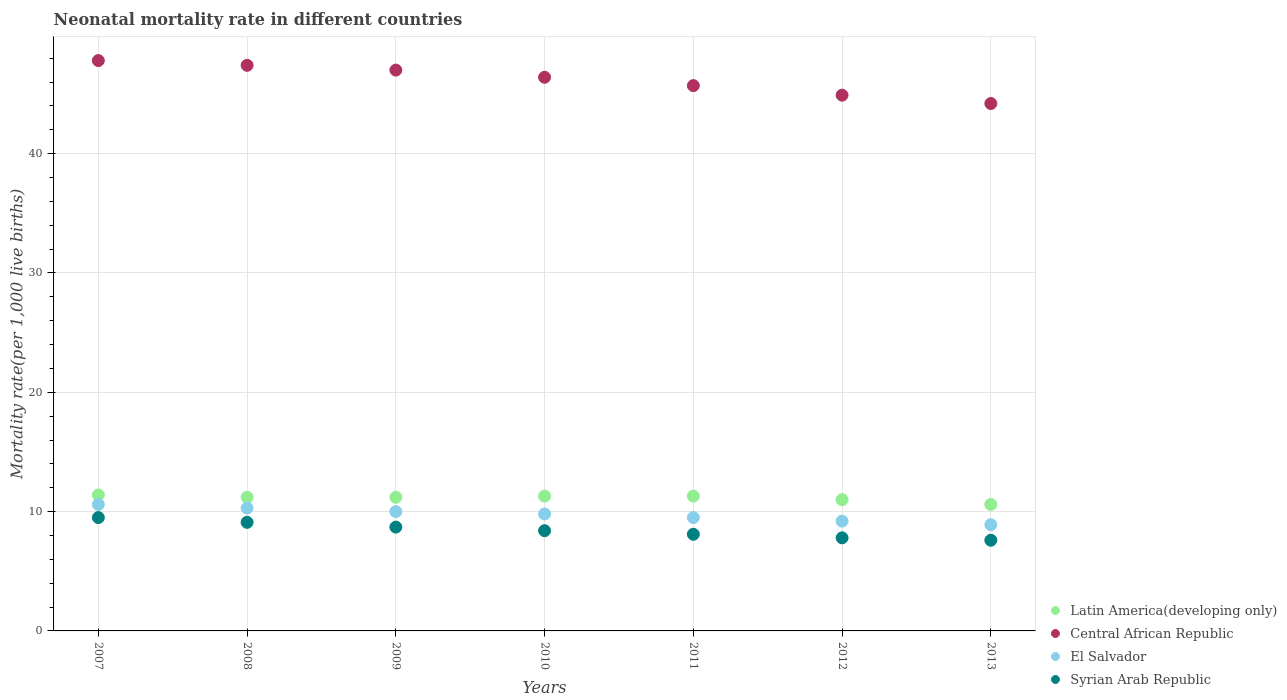How many different coloured dotlines are there?
Provide a succinct answer. 4. Is the number of dotlines equal to the number of legend labels?
Your answer should be compact. Yes. What is the neonatal mortality rate in Latin America(developing only) in 2013?
Give a very brief answer. 10.6. Across all years, what is the minimum neonatal mortality rate in El Salvador?
Your answer should be very brief. 8.9. In which year was the neonatal mortality rate in Latin America(developing only) maximum?
Your response must be concise. 2007. In which year was the neonatal mortality rate in Latin America(developing only) minimum?
Ensure brevity in your answer.  2013. What is the total neonatal mortality rate in Central African Republic in the graph?
Give a very brief answer. 323.4. What is the difference between the neonatal mortality rate in El Salvador in 2008 and that in 2009?
Provide a succinct answer. 0.3. What is the difference between the neonatal mortality rate in Central African Republic in 2013 and the neonatal mortality rate in Latin America(developing only) in 2010?
Offer a very short reply. 32.9. What is the average neonatal mortality rate in Syrian Arab Republic per year?
Offer a terse response. 8.46. In the year 2010, what is the difference between the neonatal mortality rate in Syrian Arab Republic and neonatal mortality rate in El Salvador?
Offer a very short reply. -1.4. What is the ratio of the neonatal mortality rate in Central African Republic in 2010 to that in 2011?
Your answer should be compact. 1.02. What is the difference between the highest and the second highest neonatal mortality rate in El Salvador?
Give a very brief answer. 0.3. What is the difference between the highest and the lowest neonatal mortality rate in El Salvador?
Your response must be concise. 1.7. Is the sum of the neonatal mortality rate in El Salvador in 2010 and 2012 greater than the maximum neonatal mortality rate in Central African Republic across all years?
Offer a terse response. No. Does the neonatal mortality rate in Syrian Arab Republic monotonically increase over the years?
Offer a terse response. No. Is the neonatal mortality rate in Latin America(developing only) strictly less than the neonatal mortality rate in Central African Republic over the years?
Provide a succinct answer. Yes. What is the difference between two consecutive major ticks on the Y-axis?
Your response must be concise. 10. Does the graph contain any zero values?
Offer a very short reply. No. Where does the legend appear in the graph?
Make the answer very short. Bottom right. What is the title of the graph?
Your answer should be compact. Neonatal mortality rate in different countries. Does "West Bank and Gaza" appear as one of the legend labels in the graph?
Give a very brief answer. No. What is the label or title of the X-axis?
Give a very brief answer. Years. What is the label or title of the Y-axis?
Your response must be concise. Mortality rate(per 1,0 live births). What is the Mortality rate(per 1,000 live births) in Central African Republic in 2007?
Give a very brief answer. 47.8. What is the Mortality rate(per 1,000 live births) of El Salvador in 2007?
Provide a short and direct response. 10.6. What is the Mortality rate(per 1,000 live births) of Syrian Arab Republic in 2007?
Provide a short and direct response. 9.5. What is the Mortality rate(per 1,000 live births) in Central African Republic in 2008?
Offer a very short reply. 47.4. What is the Mortality rate(per 1,000 live births) in El Salvador in 2008?
Ensure brevity in your answer.  10.3. What is the Mortality rate(per 1,000 live births) of Syrian Arab Republic in 2008?
Your answer should be compact. 9.1. What is the Mortality rate(per 1,000 live births) of Latin America(developing only) in 2009?
Keep it short and to the point. 11.2. What is the Mortality rate(per 1,000 live births) in Central African Republic in 2009?
Keep it short and to the point. 47. What is the Mortality rate(per 1,000 live births) in Syrian Arab Republic in 2009?
Make the answer very short. 8.7. What is the Mortality rate(per 1,000 live births) of Central African Republic in 2010?
Keep it short and to the point. 46.4. What is the Mortality rate(per 1,000 live births) of El Salvador in 2010?
Your response must be concise. 9.8. What is the Mortality rate(per 1,000 live births) of Syrian Arab Republic in 2010?
Make the answer very short. 8.4. What is the Mortality rate(per 1,000 live births) of Latin America(developing only) in 2011?
Your answer should be compact. 11.3. What is the Mortality rate(per 1,000 live births) of Central African Republic in 2011?
Provide a succinct answer. 45.7. What is the Mortality rate(per 1,000 live births) in Syrian Arab Republic in 2011?
Give a very brief answer. 8.1. What is the Mortality rate(per 1,000 live births) of Central African Republic in 2012?
Offer a terse response. 44.9. What is the Mortality rate(per 1,000 live births) of El Salvador in 2012?
Offer a very short reply. 9.2. What is the Mortality rate(per 1,000 live births) of Syrian Arab Republic in 2012?
Provide a short and direct response. 7.8. What is the Mortality rate(per 1,000 live births) in Latin America(developing only) in 2013?
Your answer should be very brief. 10.6. What is the Mortality rate(per 1,000 live births) in Central African Republic in 2013?
Offer a very short reply. 44.2. What is the Mortality rate(per 1,000 live births) in El Salvador in 2013?
Make the answer very short. 8.9. What is the Mortality rate(per 1,000 live births) in Syrian Arab Republic in 2013?
Give a very brief answer. 7.6. Across all years, what is the maximum Mortality rate(per 1,000 live births) of Latin America(developing only)?
Your answer should be compact. 11.4. Across all years, what is the maximum Mortality rate(per 1,000 live births) in Central African Republic?
Give a very brief answer. 47.8. Across all years, what is the maximum Mortality rate(per 1,000 live births) in El Salvador?
Provide a succinct answer. 10.6. Across all years, what is the maximum Mortality rate(per 1,000 live births) of Syrian Arab Republic?
Keep it short and to the point. 9.5. Across all years, what is the minimum Mortality rate(per 1,000 live births) of Latin America(developing only)?
Offer a very short reply. 10.6. Across all years, what is the minimum Mortality rate(per 1,000 live births) in Central African Republic?
Provide a succinct answer. 44.2. What is the total Mortality rate(per 1,000 live births) of Central African Republic in the graph?
Provide a succinct answer. 323.4. What is the total Mortality rate(per 1,000 live births) of El Salvador in the graph?
Your response must be concise. 68.3. What is the total Mortality rate(per 1,000 live births) of Syrian Arab Republic in the graph?
Offer a very short reply. 59.2. What is the difference between the Mortality rate(per 1,000 live births) in Latin America(developing only) in 2007 and that in 2008?
Provide a short and direct response. 0.2. What is the difference between the Mortality rate(per 1,000 live births) of El Salvador in 2007 and that in 2008?
Your answer should be compact. 0.3. What is the difference between the Mortality rate(per 1,000 live births) in Syrian Arab Republic in 2007 and that in 2008?
Your response must be concise. 0.4. What is the difference between the Mortality rate(per 1,000 live births) in Central African Republic in 2007 and that in 2009?
Give a very brief answer. 0.8. What is the difference between the Mortality rate(per 1,000 live births) in Syrian Arab Republic in 2007 and that in 2009?
Your answer should be compact. 0.8. What is the difference between the Mortality rate(per 1,000 live births) in El Salvador in 2007 and that in 2010?
Offer a terse response. 0.8. What is the difference between the Mortality rate(per 1,000 live births) in Syrian Arab Republic in 2007 and that in 2010?
Offer a terse response. 1.1. What is the difference between the Mortality rate(per 1,000 live births) in Central African Republic in 2007 and that in 2012?
Provide a short and direct response. 2.9. What is the difference between the Mortality rate(per 1,000 live births) in Syrian Arab Republic in 2007 and that in 2012?
Offer a very short reply. 1.7. What is the difference between the Mortality rate(per 1,000 live births) in Central African Republic in 2007 and that in 2013?
Offer a very short reply. 3.6. What is the difference between the Mortality rate(per 1,000 live births) of El Salvador in 2007 and that in 2013?
Provide a short and direct response. 1.7. What is the difference between the Mortality rate(per 1,000 live births) in Latin America(developing only) in 2008 and that in 2009?
Your answer should be compact. 0. What is the difference between the Mortality rate(per 1,000 live births) of Central African Republic in 2008 and that in 2009?
Provide a succinct answer. 0.4. What is the difference between the Mortality rate(per 1,000 live births) in Latin America(developing only) in 2008 and that in 2010?
Provide a succinct answer. -0.1. What is the difference between the Mortality rate(per 1,000 live births) of Central African Republic in 2008 and that in 2010?
Offer a terse response. 1. What is the difference between the Mortality rate(per 1,000 live births) in El Salvador in 2008 and that in 2010?
Offer a very short reply. 0.5. What is the difference between the Mortality rate(per 1,000 live births) in Central African Republic in 2008 and that in 2011?
Provide a short and direct response. 1.7. What is the difference between the Mortality rate(per 1,000 live births) in El Salvador in 2008 and that in 2011?
Keep it short and to the point. 0.8. What is the difference between the Mortality rate(per 1,000 live births) of Latin America(developing only) in 2008 and that in 2012?
Your response must be concise. 0.2. What is the difference between the Mortality rate(per 1,000 live births) in Syrian Arab Republic in 2008 and that in 2012?
Offer a very short reply. 1.3. What is the difference between the Mortality rate(per 1,000 live births) of Latin America(developing only) in 2008 and that in 2013?
Offer a very short reply. 0.6. What is the difference between the Mortality rate(per 1,000 live births) of Central African Republic in 2009 and that in 2010?
Your answer should be compact. 0.6. What is the difference between the Mortality rate(per 1,000 live births) in El Salvador in 2009 and that in 2010?
Provide a succinct answer. 0.2. What is the difference between the Mortality rate(per 1,000 live births) in Syrian Arab Republic in 2009 and that in 2010?
Offer a very short reply. 0.3. What is the difference between the Mortality rate(per 1,000 live births) of Central African Republic in 2009 and that in 2011?
Your response must be concise. 1.3. What is the difference between the Mortality rate(per 1,000 live births) of El Salvador in 2009 and that in 2011?
Provide a succinct answer. 0.5. What is the difference between the Mortality rate(per 1,000 live births) of Central African Republic in 2009 and that in 2012?
Give a very brief answer. 2.1. What is the difference between the Mortality rate(per 1,000 live births) in El Salvador in 2009 and that in 2012?
Offer a very short reply. 0.8. What is the difference between the Mortality rate(per 1,000 live births) in Syrian Arab Republic in 2009 and that in 2012?
Your answer should be compact. 0.9. What is the difference between the Mortality rate(per 1,000 live births) in Latin America(developing only) in 2009 and that in 2013?
Offer a very short reply. 0.6. What is the difference between the Mortality rate(per 1,000 live births) in Central African Republic in 2010 and that in 2011?
Provide a succinct answer. 0.7. What is the difference between the Mortality rate(per 1,000 live births) of Syrian Arab Republic in 2010 and that in 2011?
Ensure brevity in your answer.  0.3. What is the difference between the Mortality rate(per 1,000 live births) in Latin America(developing only) in 2010 and that in 2012?
Your answer should be compact. 0.3. What is the difference between the Mortality rate(per 1,000 live births) of Central African Republic in 2010 and that in 2012?
Make the answer very short. 1.5. What is the difference between the Mortality rate(per 1,000 live births) in Syrian Arab Republic in 2010 and that in 2012?
Provide a short and direct response. 0.6. What is the difference between the Mortality rate(per 1,000 live births) in Central African Republic in 2010 and that in 2013?
Provide a succinct answer. 2.2. What is the difference between the Mortality rate(per 1,000 live births) of El Salvador in 2010 and that in 2013?
Make the answer very short. 0.9. What is the difference between the Mortality rate(per 1,000 live births) in Latin America(developing only) in 2011 and that in 2012?
Ensure brevity in your answer.  0.3. What is the difference between the Mortality rate(per 1,000 live births) in El Salvador in 2011 and that in 2012?
Offer a very short reply. 0.3. What is the difference between the Mortality rate(per 1,000 live births) in Syrian Arab Republic in 2011 and that in 2012?
Your answer should be very brief. 0.3. What is the difference between the Mortality rate(per 1,000 live births) in Central African Republic in 2011 and that in 2013?
Give a very brief answer. 1.5. What is the difference between the Mortality rate(per 1,000 live births) in El Salvador in 2011 and that in 2013?
Your answer should be very brief. 0.6. What is the difference between the Mortality rate(per 1,000 live births) in Syrian Arab Republic in 2011 and that in 2013?
Provide a short and direct response. 0.5. What is the difference between the Mortality rate(per 1,000 live births) in Central African Republic in 2012 and that in 2013?
Give a very brief answer. 0.7. What is the difference between the Mortality rate(per 1,000 live births) of Latin America(developing only) in 2007 and the Mortality rate(per 1,000 live births) of Central African Republic in 2008?
Offer a very short reply. -36. What is the difference between the Mortality rate(per 1,000 live births) of Latin America(developing only) in 2007 and the Mortality rate(per 1,000 live births) of Syrian Arab Republic in 2008?
Give a very brief answer. 2.3. What is the difference between the Mortality rate(per 1,000 live births) of Central African Republic in 2007 and the Mortality rate(per 1,000 live births) of El Salvador in 2008?
Your answer should be compact. 37.5. What is the difference between the Mortality rate(per 1,000 live births) in Central African Republic in 2007 and the Mortality rate(per 1,000 live births) in Syrian Arab Republic in 2008?
Give a very brief answer. 38.7. What is the difference between the Mortality rate(per 1,000 live births) of Latin America(developing only) in 2007 and the Mortality rate(per 1,000 live births) of Central African Republic in 2009?
Offer a very short reply. -35.6. What is the difference between the Mortality rate(per 1,000 live births) in Latin America(developing only) in 2007 and the Mortality rate(per 1,000 live births) in El Salvador in 2009?
Your answer should be very brief. 1.4. What is the difference between the Mortality rate(per 1,000 live births) of Latin America(developing only) in 2007 and the Mortality rate(per 1,000 live births) of Syrian Arab Republic in 2009?
Your answer should be very brief. 2.7. What is the difference between the Mortality rate(per 1,000 live births) in Central African Republic in 2007 and the Mortality rate(per 1,000 live births) in El Salvador in 2009?
Keep it short and to the point. 37.8. What is the difference between the Mortality rate(per 1,000 live births) in Central African Republic in 2007 and the Mortality rate(per 1,000 live births) in Syrian Arab Republic in 2009?
Ensure brevity in your answer.  39.1. What is the difference between the Mortality rate(per 1,000 live births) of El Salvador in 2007 and the Mortality rate(per 1,000 live births) of Syrian Arab Republic in 2009?
Your answer should be compact. 1.9. What is the difference between the Mortality rate(per 1,000 live births) of Latin America(developing only) in 2007 and the Mortality rate(per 1,000 live births) of Central African Republic in 2010?
Keep it short and to the point. -35. What is the difference between the Mortality rate(per 1,000 live births) of Latin America(developing only) in 2007 and the Mortality rate(per 1,000 live births) of El Salvador in 2010?
Keep it short and to the point. 1.6. What is the difference between the Mortality rate(per 1,000 live births) in Central African Republic in 2007 and the Mortality rate(per 1,000 live births) in El Salvador in 2010?
Provide a short and direct response. 38. What is the difference between the Mortality rate(per 1,000 live births) in Central African Republic in 2007 and the Mortality rate(per 1,000 live births) in Syrian Arab Republic in 2010?
Give a very brief answer. 39.4. What is the difference between the Mortality rate(per 1,000 live births) of Latin America(developing only) in 2007 and the Mortality rate(per 1,000 live births) of Central African Republic in 2011?
Keep it short and to the point. -34.3. What is the difference between the Mortality rate(per 1,000 live births) in Latin America(developing only) in 2007 and the Mortality rate(per 1,000 live births) in El Salvador in 2011?
Ensure brevity in your answer.  1.9. What is the difference between the Mortality rate(per 1,000 live births) of Latin America(developing only) in 2007 and the Mortality rate(per 1,000 live births) of Syrian Arab Republic in 2011?
Provide a succinct answer. 3.3. What is the difference between the Mortality rate(per 1,000 live births) of Central African Republic in 2007 and the Mortality rate(per 1,000 live births) of El Salvador in 2011?
Your answer should be compact. 38.3. What is the difference between the Mortality rate(per 1,000 live births) in Central African Republic in 2007 and the Mortality rate(per 1,000 live births) in Syrian Arab Republic in 2011?
Your answer should be compact. 39.7. What is the difference between the Mortality rate(per 1,000 live births) of Latin America(developing only) in 2007 and the Mortality rate(per 1,000 live births) of Central African Republic in 2012?
Your answer should be very brief. -33.5. What is the difference between the Mortality rate(per 1,000 live births) in Latin America(developing only) in 2007 and the Mortality rate(per 1,000 live births) in El Salvador in 2012?
Your answer should be compact. 2.2. What is the difference between the Mortality rate(per 1,000 live births) in Central African Republic in 2007 and the Mortality rate(per 1,000 live births) in El Salvador in 2012?
Your response must be concise. 38.6. What is the difference between the Mortality rate(per 1,000 live births) of Latin America(developing only) in 2007 and the Mortality rate(per 1,000 live births) of Central African Republic in 2013?
Ensure brevity in your answer.  -32.8. What is the difference between the Mortality rate(per 1,000 live births) in Latin America(developing only) in 2007 and the Mortality rate(per 1,000 live births) in Syrian Arab Republic in 2013?
Provide a succinct answer. 3.8. What is the difference between the Mortality rate(per 1,000 live births) of Central African Republic in 2007 and the Mortality rate(per 1,000 live births) of El Salvador in 2013?
Your response must be concise. 38.9. What is the difference between the Mortality rate(per 1,000 live births) in Central African Republic in 2007 and the Mortality rate(per 1,000 live births) in Syrian Arab Republic in 2013?
Offer a very short reply. 40.2. What is the difference between the Mortality rate(per 1,000 live births) in Latin America(developing only) in 2008 and the Mortality rate(per 1,000 live births) in Central African Republic in 2009?
Your answer should be compact. -35.8. What is the difference between the Mortality rate(per 1,000 live births) of Latin America(developing only) in 2008 and the Mortality rate(per 1,000 live births) of El Salvador in 2009?
Give a very brief answer. 1.2. What is the difference between the Mortality rate(per 1,000 live births) in Central African Republic in 2008 and the Mortality rate(per 1,000 live births) in El Salvador in 2009?
Your response must be concise. 37.4. What is the difference between the Mortality rate(per 1,000 live births) in Central African Republic in 2008 and the Mortality rate(per 1,000 live births) in Syrian Arab Republic in 2009?
Keep it short and to the point. 38.7. What is the difference between the Mortality rate(per 1,000 live births) of El Salvador in 2008 and the Mortality rate(per 1,000 live births) of Syrian Arab Republic in 2009?
Your answer should be very brief. 1.6. What is the difference between the Mortality rate(per 1,000 live births) of Latin America(developing only) in 2008 and the Mortality rate(per 1,000 live births) of Central African Republic in 2010?
Your response must be concise. -35.2. What is the difference between the Mortality rate(per 1,000 live births) of Latin America(developing only) in 2008 and the Mortality rate(per 1,000 live births) of Syrian Arab Republic in 2010?
Your answer should be compact. 2.8. What is the difference between the Mortality rate(per 1,000 live births) in Central African Republic in 2008 and the Mortality rate(per 1,000 live births) in El Salvador in 2010?
Keep it short and to the point. 37.6. What is the difference between the Mortality rate(per 1,000 live births) in Central African Republic in 2008 and the Mortality rate(per 1,000 live births) in Syrian Arab Republic in 2010?
Your answer should be very brief. 39. What is the difference between the Mortality rate(per 1,000 live births) of El Salvador in 2008 and the Mortality rate(per 1,000 live births) of Syrian Arab Republic in 2010?
Your answer should be compact. 1.9. What is the difference between the Mortality rate(per 1,000 live births) of Latin America(developing only) in 2008 and the Mortality rate(per 1,000 live births) of Central African Republic in 2011?
Provide a succinct answer. -34.5. What is the difference between the Mortality rate(per 1,000 live births) of Latin America(developing only) in 2008 and the Mortality rate(per 1,000 live births) of Syrian Arab Republic in 2011?
Your answer should be compact. 3.1. What is the difference between the Mortality rate(per 1,000 live births) in Central African Republic in 2008 and the Mortality rate(per 1,000 live births) in El Salvador in 2011?
Offer a very short reply. 37.9. What is the difference between the Mortality rate(per 1,000 live births) of Central African Republic in 2008 and the Mortality rate(per 1,000 live births) of Syrian Arab Republic in 2011?
Provide a succinct answer. 39.3. What is the difference between the Mortality rate(per 1,000 live births) in Latin America(developing only) in 2008 and the Mortality rate(per 1,000 live births) in Central African Republic in 2012?
Your answer should be very brief. -33.7. What is the difference between the Mortality rate(per 1,000 live births) in Latin America(developing only) in 2008 and the Mortality rate(per 1,000 live births) in Syrian Arab Republic in 2012?
Your response must be concise. 3.4. What is the difference between the Mortality rate(per 1,000 live births) in Central African Republic in 2008 and the Mortality rate(per 1,000 live births) in El Salvador in 2012?
Offer a very short reply. 38.2. What is the difference between the Mortality rate(per 1,000 live births) in Central African Republic in 2008 and the Mortality rate(per 1,000 live births) in Syrian Arab Republic in 2012?
Your answer should be compact. 39.6. What is the difference between the Mortality rate(per 1,000 live births) of El Salvador in 2008 and the Mortality rate(per 1,000 live births) of Syrian Arab Republic in 2012?
Give a very brief answer. 2.5. What is the difference between the Mortality rate(per 1,000 live births) of Latin America(developing only) in 2008 and the Mortality rate(per 1,000 live births) of Central African Republic in 2013?
Your response must be concise. -33. What is the difference between the Mortality rate(per 1,000 live births) of Latin America(developing only) in 2008 and the Mortality rate(per 1,000 live births) of El Salvador in 2013?
Provide a short and direct response. 2.3. What is the difference between the Mortality rate(per 1,000 live births) of Latin America(developing only) in 2008 and the Mortality rate(per 1,000 live births) of Syrian Arab Republic in 2013?
Keep it short and to the point. 3.6. What is the difference between the Mortality rate(per 1,000 live births) in Central African Republic in 2008 and the Mortality rate(per 1,000 live births) in El Salvador in 2013?
Keep it short and to the point. 38.5. What is the difference between the Mortality rate(per 1,000 live births) in Central African Republic in 2008 and the Mortality rate(per 1,000 live births) in Syrian Arab Republic in 2013?
Your response must be concise. 39.8. What is the difference between the Mortality rate(per 1,000 live births) in Latin America(developing only) in 2009 and the Mortality rate(per 1,000 live births) in Central African Republic in 2010?
Offer a terse response. -35.2. What is the difference between the Mortality rate(per 1,000 live births) in Central African Republic in 2009 and the Mortality rate(per 1,000 live births) in El Salvador in 2010?
Provide a succinct answer. 37.2. What is the difference between the Mortality rate(per 1,000 live births) in Central African Republic in 2009 and the Mortality rate(per 1,000 live births) in Syrian Arab Republic in 2010?
Your answer should be very brief. 38.6. What is the difference between the Mortality rate(per 1,000 live births) of El Salvador in 2009 and the Mortality rate(per 1,000 live births) of Syrian Arab Republic in 2010?
Provide a short and direct response. 1.6. What is the difference between the Mortality rate(per 1,000 live births) in Latin America(developing only) in 2009 and the Mortality rate(per 1,000 live births) in Central African Republic in 2011?
Make the answer very short. -34.5. What is the difference between the Mortality rate(per 1,000 live births) in Latin America(developing only) in 2009 and the Mortality rate(per 1,000 live births) in El Salvador in 2011?
Keep it short and to the point. 1.7. What is the difference between the Mortality rate(per 1,000 live births) of Central African Republic in 2009 and the Mortality rate(per 1,000 live births) of El Salvador in 2011?
Your response must be concise. 37.5. What is the difference between the Mortality rate(per 1,000 live births) in Central African Republic in 2009 and the Mortality rate(per 1,000 live births) in Syrian Arab Republic in 2011?
Ensure brevity in your answer.  38.9. What is the difference between the Mortality rate(per 1,000 live births) of El Salvador in 2009 and the Mortality rate(per 1,000 live births) of Syrian Arab Republic in 2011?
Provide a short and direct response. 1.9. What is the difference between the Mortality rate(per 1,000 live births) in Latin America(developing only) in 2009 and the Mortality rate(per 1,000 live births) in Central African Republic in 2012?
Ensure brevity in your answer.  -33.7. What is the difference between the Mortality rate(per 1,000 live births) of Latin America(developing only) in 2009 and the Mortality rate(per 1,000 live births) of El Salvador in 2012?
Offer a very short reply. 2. What is the difference between the Mortality rate(per 1,000 live births) in Central African Republic in 2009 and the Mortality rate(per 1,000 live births) in El Salvador in 2012?
Your answer should be compact. 37.8. What is the difference between the Mortality rate(per 1,000 live births) of Central African Republic in 2009 and the Mortality rate(per 1,000 live births) of Syrian Arab Republic in 2012?
Provide a short and direct response. 39.2. What is the difference between the Mortality rate(per 1,000 live births) in El Salvador in 2009 and the Mortality rate(per 1,000 live births) in Syrian Arab Republic in 2012?
Ensure brevity in your answer.  2.2. What is the difference between the Mortality rate(per 1,000 live births) of Latin America(developing only) in 2009 and the Mortality rate(per 1,000 live births) of Central African Republic in 2013?
Give a very brief answer. -33. What is the difference between the Mortality rate(per 1,000 live births) of Central African Republic in 2009 and the Mortality rate(per 1,000 live births) of El Salvador in 2013?
Provide a short and direct response. 38.1. What is the difference between the Mortality rate(per 1,000 live births) of Central African Republic in 2009 and the Mortality rate(per 1,000 live births) of Syrian Arab Republic in 2013?
Ensure brevity in your answer.  39.4. What is the difference between the Mortality rate(per 1,000 live births) in Latin America(developing only) in 2010 and the Mortality rate(per 1,000 live births) in Central African Republic in 2011?
Provide a short and direct response. -34.4. What is the difference between the Mortality rate(per 1,000 live births) of Latin America(developing only) in 2010 and the Mortality rate(per 1,000 live births) of El Salvador in 2011?
Provide a short and direct response. 1.8. What is the difference between the Mortality rate(per 1,000 live births) of Latin America(developing only) in 2010 and the Mortality rate(per 1,000 live births) of Syrian Arab Republic in 2011?
Provide a short and direct response. 3.2. What is the difference between the Mortality rate(per 1,000 live births) of Central African Republic in 2010 and the Mortality rate(per 1,000 live births) of El Salvador in 2011?
Your response must be concise. 36.9. What is the difference between the Mortality rate(per 1,000 live births) of Central African Republic in 2010 and the Mortality rate(per 1,000 live births) of Syrian Arab Republic in 2011?
Your answer should be very brief. 38.3. What is the difference between the Mortality rate(per 1,000 live births) in El Salvador in 2010 and the Mortality rate(per 1,000 live births) in Syrian Arab Republic in 2011?
Keep it short and to the point. 1.7. What is the difference between the Mortality rate(per 1,000 live births) in Latin America(developing only) in 2010 and the Mortality rate(per 1,000 live births) in Central African Republic in 2012?
Provide a succinct answer. -33.6. What is the difference between the Mortality rate(per 1,000 live births) in Latin America(developing only) in 2010 and the Mortality rate(per 1,000 live births) in El Salvador in 2012?
Make the answer very short. 2.1. What is the difference between the Mortality rate(per 1,000 live births) of Central African Republic in 2010 and the Mortality rate(per 1,000 live births) of El Salvador in 2012?
Provide a short and direct response. 37.2. What is the difference between the Mortality rate(per 1,000 live births) in Central African Republic in 2010 and the Mortality rate(per 1,000 live births) in Syrian Arab Republic in 2012?
Keep it short and to the point. 38.6. What is the difference between the Mortality rate(per 1,000 live births) in Latin America(developing only) in 2010 and the Mortality rate(per 1,000 live births) in Central African Republic in 2013?
Your response must be concise. -32.9. What is the difference between the Mortality rate(per 1,000 live births) in Latin America(developing only) in 2010 and the Mortality rate(per 1,000 live births) in El Salvador in 2013?
Give a very brief answer. 2.4. What is the difference between the Mortality rate(per 1,000 live births) in Central African Republic in 2010 and the Mortality rate(per 1,000 live births) in El Salvador in 2013?
Give a very brief answer. 37.5. What is the difference between the Mortality rate(per 1,000 live births) of Central African Republic in 2010 and the Mortality rate(per 1,000 live births) of Syrian Arab Republic in 2013?
Provide a succinct answer. 38.8. What is the difference between the Mortality rate(per 1,000 live births) of El Salvador in 2010 and the Mortality rate(per 1,000 live births) of Syrian Arab Republic in 2013?
Your answer should be compact. 2.2. What is the difference between the Mortality rate(per 1,000 live births) in Latin America(developing only) in 2011 and the Mortality rate(per 1,000 live births) in Central African Republic in 2012?
Provide a succinct answer. -33.6. What is the difference between the Mortality rate(per 1,000 live births) of Latin America(developing only) in 2011 and the Mortality rate(per 1,000 live births) of El Salvador in 2012?
Your answer should be compact. 2.1. What is the difference between the Mortality rate(per 1,000 live births) in Central African Republic in 2011 and the Mortality rate(per 1,000 live births) in El Salvador in 2012?
Provide a succinct answer. 36.5. What is the difference between the Mortality rate(per 1,000 live births) of Central African Republic in 2011 and the Mortality rate(per 1,000 live births) of Syrian Arab Republic in 2012?
Make the answer very short. 37.9. What is the difference between the Mortality rate(per 1,000 live births) in El Salvador in 2011 and the Mortality rate(per 1,000 live births) in Syrian Arab Republic in 2012?
Your answer should be compact. 1.7. What is the difference between the Mortality rate(per 1,000 live births) of Latin America(developing only) in 2011 and the Mortality rate(per 1,000 live births) of Central African Republic in 2013?
Keep it short and to the point. -32.9. What is the difference between the Mortality rate(per 1,000 live births) of Central African Republic in 2011 and the Mortality rate(per 1,000 live births) of El Salvador in 2013?
Your answer should be very brief. 36.8. What is the difference between the Mortality rate(per 1,000 live births) of Central African Republic in 2011 and the Mortality rate(per 1,000 live births) of Syrian Arab Republic in 2013?
Offer a terse response. 38.1. What is the difference between the Mortality rate(per 1,000 live births) of El Salvador in 2011 and the Mortality rate(per 1,000 live births) of Syrian Arab Republic in 2013?
Provide a succinct answer. 1.9. What is the difference between the Mortality rate(per 1,000 live births) of Latin America(developing only) in 2012 and the Mortality rate(per 1,000 live births) of Central African Republic in 2013?
Provide a short and direct response. -33.2. What is the difference between the Mortality rate(per 1,000 live births) in Latin America(developing only) in 2012 and the Mortality rate(per 1,000 live births) in Syrian Arab Republic in 2013?
Ensure brevity in your answer.  3.4. What is the difference between the Mortality rate(per 1,000 live births) of Central African Republic in 2012 and the Mortality rate(per 1,000 live births) of El Salvador in 2013?
Give a very brief answer. 36. What is the difference between the Mortality rate(per 1,000 live births) of Central African Republic in 2012 and the Mortality rate(per 1,000 live births) of Syrian Arab Republic in 2013?
Ensure brevity in your answer.  37.3. What is the difference between the Mortality rate(per 1,000 live births) in El Salvador in 2012 and the Mortality rate(per 1,000 live births) in Syrian Arab Republic in 2013?
Give a very brief answer. 1.6. What is the average Mortality rate(per 1,000 live births) in Latin America(developing only) per year?
Give a very brief answer. 11.14. What is the average Mortality rate(per 1,000 live births) in Central African Republic per year?
Provide a succinct answer. 46.2. What is the average Mortality rate(per 1,000 live births) of El Salvador per year?
Your answer should be very brief. 9.76. What is the average Mortality rate(per 1,000 live births) in Syrian Arab Republic per year?
Offer a very short reply. 8.46. In the year 2007, what is the difference between the Mortality rate(per 1,000 live births) of Latin America(developing only) and Mortality rate(per 1,000 live births) of Central African Republic?
Your answer should be compact. -36.4. In the year 2007, what is the difference between the Mortality rate(per 1,000 live births) in Latin America(developing only) and Mortality rate(per 1,000 live births) in Syrian Arab Republic?
Your answer should be very brief. 1.9. In the year 2007, what is the difference between the Mortality rate(per 1,000 live births) of Central African Republic and Mortality rate(per 1,000 live births) of El Salvador?
Keep it short and to the point. 37.2. In the year 2007, what is the difference between the Mortality rate(per 1,000 live births) in Central African Republic and Mortality rate(per 1,000 live births) in Syrian Arab Republic?
Provide a short and direct response. 38.3. In the year 2007, what is the difference between the Mortality rate(per 1,000 live births) of El Salvador and Mortality rate(per 1,000 live births) of Syrian Arab Republic?
Your answer should be very brief. 1.1. In the year 2008, what is the difference between the Mortality rate(per 1,000 live births) in Latin America(developing only) and Mortality rate(per 1,000 live births) in Central African Republic?
Offer a terse response. -36.2. In the year 2008, what is the difference between the Mortality rate(per 1,000 live births) of Latin America(developing only) and Mortality rate(per 1,000 live births) of El Salvador?
Your response must be concise. 0.9. In the year 2008, what is the difference between the Mortality rate(per 1,000 live births) in Latin America(developing only) and Mortality rate(per 1,000 live births) in Syrian Arab Republic?
Provide a succinct answer. 2.1. In the year 2008, what is the difference between the Mortality rate(per 1,000 live births) of Central African Republic and Mortality rate(per 1,000 live births) of El Salvador?
Make the answer very short. 37.1. In the year 2008, what is the difference between the Mortality rate(per 1,000 live births) in Central African Republic and Mortality rate(per 1,000 live births) in Syrian Arab Republic?
Provide a succinct answer. 38.3. In the year 2009, what is the difference between the Mortality rate(per 1,000 live births) of Latin America(developing only) and Mortality rate(per 1,000 live births) of Central African Republic?
Provide a succinct answer. -35.8. In the year 2009, what is the difference between the Mortality rate(per 1,000 live births) of Latin America(developing only) and Mortality rate(per 1,000 live births) of El Salvador?
Keep it short and to the point. 1.2. In the year 2009, what is the difference between the Mortality rate(per 1,000 live births) in Central African Republic and Mortality rate(per 1,000 live births) in Syrian Arab Republic?
Your response must be concise. 38.3. In the year 2010, what is the difference between the Mortality rate(per 1,000 live births) of Latin America(developing only) and Mortality rate(per 1,000 live births) of Central African Republic?
Offer a terse response. -35.1. In the year 2010, what is the difference between the Mortality rate(per 1,000 live births) in Latin America(developing only) and Mortality rate(per 1,000 live births) in Syrian Arab Republic?
Give a very brief answer. 2.9. In the year 2010, what is the difference between the Mortality rate(per 1,000 live births) in Central African Republic and Mortality rate(per 1,000 live births) in El Salvador?
Provide a succinct answer. 36.6. In the year 2010, what is the difference between the Mortality rate(per 1,000 live births) in Central African Republic and Mortality rate(per 1,000 live births) in Syrian Arab Republic?
Make the answer very short. 38. In the year 2011, what is the difference between the Mortality rate(per 1,000 live births) of Latin America(developing only) and Mortality rate(per 1,000 live births) of Central African Republic?
Offer a very short reply. -34.4. In the year 2011, what is the difference between the Mortality rate(per 1,000 live births) of Latin America(developing only) and Mortality rate(per 1,000 live births) of El Salvador?
Provide a succinct answer. 1.8. In the year 2011, what is the difference between the Mortality rate(per 1,000 live births) in Central African Republic and Mortality rate(per 1,000 live births) in El Salvador?
Your response must be concise. 36.2. In the year 2011, what is the difference between the Mortality rate(per 1,000 live births) in Central African Republic and Mortality rate(per 1,000 live births) in Syrian Arab Republic?
Your response must be concise. 37.6. In the year 2012, what is the difference between the Mortality rate(per 1,000 live births) of Latin America(developing only) and Mortality rate(per 1,000 live births) of Central African Republic?
Provide a short and direct response. -33.9. In the year 2012, what is the difference between the Mortality rate(per 1,000 live births) of Latin America(developing only) and Mortality rate(per 1,000 live births) of El Salvador?
Your response must be concise. 1.8. In the year 2012, what is the difference between the Mortality rate(per 1,000 live births) in Latin America(developing only) and Mortality rate(per 1,000 live births) in Syrian Arab Republic?
Offer a very short reply. 3.2. In the year 2012, what is the difference between the Mortality rate(per 1,000 live births) of Central African Republic and Mortality rate(per 1,000 live births) of El Salvador?
Give a very brief answer. 35.7. In the year 2012, what is the difference between the Mortality rate(per 1,000 live births) of Central African Republic and Mortality rate(per 1,000 live births) of Syrian Arab Republic?
Keep it short and to the point. 37.1. In the year 2013, what is the difference between the Mortality rate(per 1,000 live births) in Latin America(developing only) and Mortality rate(per 1,000 live births) in Central African Republic?
Keep it short and to the point. -33.6. In the year 2013, what is the difference between the Mortality rate(per 1,000 live births) of Latin America(developing only) and Mortality rate(per 1,000 live births) of El Salvador?
Offer a terse response. 1.7. In the year 2013, what is the difference between the Mortality rate(per 1,000 live births) of Latin America(developing only) and Mortality rate(per 1,000 live births) of Syrian Arab Republic?
Your answer should be compact. 3. In the year 2013, what is the difference between the Mortality rate(per 1,000 live births) of Central African Republic and Mortality rate(per 1,000 live births) of El Salvador?
Your answer should be compact. 35.3. In the year 2013, what is the difference between the Mortality rate(per 1,000 live births) in Central African Republic and Mortality rate(per 1,000 live births) in Syrian Arab Republic?
Your response must be concise. 36.6. What is the ratio of the Mortality rate(per 1,000 live births) of Latin America(developing only) in 2007 to that in 2008?
Keep it short and to the point. 1.02. What is the ratio of the Mortality rate(per 1,000 live births) in Central African Republic in 2007 to that in 2008?
Your answer should be very brief. 1.01. What is the ratio of the Mortality rate(per 1,000 live births) of El Salvador in 2007 to that in 2008?
Your response must be concise. 1.03. What is the ratio of the Mortality rate(per 1,000 live births) in Syrian Arab Republic in 2007 to that in 2008?
Offer a terse response. 1.04. What is the ratio of the Mortality rate(per 1,000 live births) of Latin America(developing only) in 2007 to that in 2009?
Give a very brief answer. 1.02. What is the ratio of the Mortality rate(per 1,000 live births) in El Salvador in 2007 to that in 2009?
Your answer should be compact. 1.06. What is the ratio of the Mortality rate(per 1,000 live births) in Syrian Arab Republic in 2007 to that in 2009?
Make the answer very short. 1.09. What is the ratio of the Mortality rate(per 1,000 live births) of Latin America(developing only) in 2007 to that in 2010?
Keep it short and to the point. 1.01. What is the ratio of the Mortality rate(per 1,000 live births) in Central African Republic in 2007 to that in 2010?
Offer a terse response. 1.03. What is the ratio of the Mortality rate(per 1,000 live births) of El Salvador in 2007 to that in 2010?
Your answer should be compact. 1.08. What is the ratio of the Mortality rate(per 1,000 live births) in Syrian Arab Republic in 2007 to that in 2010?
Offer a terse response. 1.13. What is the ratio of the Mortality rate(per 1,000 live births) of Latin America(developing only) in 2007 to that in 2011?
Your answer should be very brief. 1.01. What is the ratio of the Mortality rate(per 1,000 live births) of Central African Republic in 2007 to that in 2011?
Provide a short and direct response. 1.05. What is the ratio of the Mortality rate(per 1,000 live births) of El Salvador in 2007 to that in 2011?
Give a very brief answer. 1.12. What is the ratio of the Mortality rate(per 1,000 live births) in Syrian Arab Republic in 2007 to that in 2011?
Keep it short and to the point. 1.17. What is the ratio of the Mortality rate(per 1,000 live births) of Latin America(developing only) in 2007 to that in 2012?
Your response must be concise. 1.04. What is the ratio of the Mortality rate(per 1,000 live births) of Central African Republic in 2007 to that in 2012?
Your response must be concise. 1.06. What is the ratio of the Mortality rate(per 1,000 live births) of El Salvador in 2007 to that in 2012?
Your response must be concise. 1.15. What is the ratio of the Mortality rate(per 1,000 live births) in Syrian Arab Republic in 2007 to that in 2012?
Offer a terse response. 1.22. What is the ratio of the Mortality rate(per 1,000 live births) in Latin America(developing only) in 2007 to that in 2013?
Offer a terse response. 1.08. What is the ratio of the Mortality rate(per 1,000 live births) of Central African Republic in 2007 to that in 2013?
Provide a short and direct response. 1.08. What is the ratio of the Mortality rate(per 1,000 live births) in El Salvador in 2007 to that in 2013?
Your response must be concise. 1.19. What is the ratio of the Mortality rate(per 1,000 live births) of Syrian Arab Republic in 2007 to that in 2013?
Your response must be concise. 1.25. What is the ratio of the Mortality rate(per 1,000 live births) of Central African Republic in 2008 to that in 2009?
Ensure brevity in your answer.  1.01. What is the ratio of the Mortality rate(per 1,000 live births) of Syrian Arab Republic in 2008 to that in 2009?
Keep it short and to the point. 1.05. What is the ratio of the Mortality rate(per 1,000 live births) of Latin America(developing only) in 2008 to that in 2010?
Make the answer very short. 0.99. What is the ratio of the Mortality rate(per 1,000 live births) in Central African Republic in 2008 to that in 2010?
Your response must be concise. 1.02. What is the ratio of the Mortality rate(per 1,000 live births) of El Salvador in 2008 to that in 2010?
Offer a very short reply. 1.05. What is the ratio of the Mortality rate(per 1,000 live births) of Central African Republic in 2008 to that in 2011?
Your response must be concise. 1.04. What is the ratio of the Mortality rate(per 1,000 live births) in El Salvador in 2008 to that in 2011?
Make the answer very short. 1.08. What is the ratio of the Mortality rate(per 1,000 live births) of Syrian Arab Republic in 2008 to that in 2011?
Provide a succinct answer. 1.12. What is the ratio of the Mortality rate(per 1,000 live births) of Latin America(developing only) in 2008 to that in 2012?
Give a very brief answer. 1.02. What is the ratio of the Mortality rate(per 1,000 live births) in Central African Republic in 2008 to that in 2012?
Keep it short and to the point. 1.06. What is the ratio of the Mortality rate(per 1,000 live births) of El Salvador in 2008 to that in 2012?
Keep it short and to the point. 1.12. What is the ratio of the Mortality rate(per 1,000 live births) in Latin America(developing only) in 2008 to that in 2013?
Your answer should be very brief. 1.06. What is the ratio of the Mortality rate(per 1,000 live births) of Central African Republic in 2008 to that in 2013?
Offer a very short reply. 1.07. What is the ratio of the Mortality rate(per 1,000 live births) of El Salvador in 2008 to that in 2013?
Ensure brevity in your answer.  1.16. What is the ratio of the Mortality rate(per 1,000 live births) of Syrian Arab Republic in 2008 to that in 2013?
Your answer should be compact. 1.2. What is the ratio of the Mortality rate(per 1,000 live births) in Central African Republic in 2009 to that in 2010?
Make the answer very short. 1.01. What is the ratio of the Mortality rate(per 1,000 live births) of El Salvador in 2009 to that in 2010?
Make the answer very short. 1.02. What is the ratio of the Mortality rate(per 1,000 live births) of Syrian Arab Republic in 2009 to that in 2010?
Ensure brevity in your answer.  1.04. What is the ratio of the Mortality rate(per 1,000 live births) of Latin America(developing only) in 2009 to that in 2011?
Give a very brief answer. 0.99. What is the ratio of the Mortality rate(per 1,000 live births) of Central African Republic in 2009 to that in 2011?
Offer a very short reply. 1.03. What is the ratio of the Mortality rate(per 1,000 live births) in El Salvador in 2009 to that in 2011?
Your answer should be compact. 1.05. What is the ratio of the Mortality rate(per 1,000 live births) of Syrian Arab Republic in 2009 to that in 2011?
Keep it short and to the point. 1.07. What is the ratio of the Mortality rate(per 1,000 live births) in Latin America(developing only) in 2009 to that in 2012?
Give a very brief answer. 1.02. What is the ratio of the Mortality rate(per 1,000 live births) of Central African Republic in 2009 to that in 2012?
Keep it short and to the point. 1.05. What is the ratio of the Mortality rate(per 1,000 live births) of El Salvador in 2009 to that in 2012?
Offer a very short reply. 1.09. What is the ratio of the Mortality rate(per 1,000 live births) of Syrian Arab Republic in 2009 to that in 2012?
Your answer should be compact. 1.12. What is the ratio of the Mortality rate(per 1,000 live births) of Latin America(developing only) in 2009 to that in 2013?
Provide a succinct answer. 1.06. What is the ratio of the Mortality rate(per 1,000 live births) in Central African Republic in 2009 to that in 2013?
Ensure brevity in your answer.  1.06. What is the ratio of the Mortality rate(per 1,000 live births) in El Salvador in 2009 to that in 2013?
Provide a succinct answer. 1.12. What is the ratio of the Mortality rate(per 1,000 live births) of Syrian Arab Republic in 2009 to that in 2013?
Your answer should be compact. 1.14. What is the ratio of the Mortality rate(per 1,000 live births) in Latin America(developing only) in 2010 to that in 2011?
Give a very brief answer. 1. What is the ratio of the Mortality rate(per 1,000 live births) of Central African Republic in 2010 to that in 2011?
Your response must be concise. 1.02. What is the ratio of the Mortality rate(per 1,000 live births) in El Salvador in 2010 to that in 2011?
Offer a terse response. 1.03. What is the ratio of the Mortality rate(per 1,000 live births) in Latin America(developing only) in 2010 to that in 2012?
Your answer should be compact. 1.03. What is the ratio of the Mortality rate(per 1,000 live births) in Central African Republic in 2010 to that in 2012?
Your answer should be very brief. 1.03. What is the ratio of the Mortality rate(per 1,000 live births) of El Salvador in 2010 to that in 2012?
Your response must be concise. 1.07. What is the ratio of the Mortality rate(per 1,000 live births) in Latin America(developing only) in 2010 to that in 2013?
Make the answer very short. 1.07. What is the ratio of the Mortality rate(per 1,000 live births) of Central African Republic in 2010 to that in 2013?
Offer a very short reply. 1.05. What is the ratio of the Mortality rate(per 1,000 live births) in El Salvador in 2010 to that in 2013?
Your response must be concise. 1.1. What is the ratio of the Mortality rate(per 1,000 live births) in Syrian Arab Republic in 2010 to that in 2013?
Offer a terse response. 1.11. What is the ratio of the Mortality rate(per 1,000 live births) of Latin America(developing only) in 2011 to that in 2012?
Your answer should be very brief. 1.03. What is the ratio of the Mortality rate(per 1,000 live births) in Central African Republic in 2011 to that in 2012?
Provide a succinct answer. 1.02. What is the ratio of the Mortality rate(per 1,000 live births) of El Salvador in 2011 to that in 2012?
Keep it short and to the point. 1.03. What is the ratio of the Mortality rate(per 1,000 live births) of Latin America(developing only) in 2011 to that in 2013?
Offer a terse response. 1.07. What is the ratio of the Mortality rate(per 1,000 live births) in Central African Republic in 2011 to that in 2013?
Provide a succinct answer. 1.03. What is the ratio of the Mortality rate(per 1,000 live births) of El Salvador in 2011 to that in 2013?
Provide a succinct answer. 1.07. What is the ratio of the Mortality rate(per 1,000 live births) of Syrian Arab Republic in 2011 to that in 2013?
Offer a very short reply. 1.07. What is the ratio of the Mortality rate(per 1,000 live births) of Latin America(developing only) in 2012 to that in 2013?
Offer a terse response. 1.04. What is the ratio of the Mortality rate(per 1,000 live births) in Central African Republic in 2012 to that in 2013?
Give a very brief answer. 1.02. What is the ratio of the Mortality rate(per 1,000 live births) in El Salvador in 2012 to that in 2013?
Ensure brevity in your answer.  1.03. What is the ratio of the Mortality rate(per 1,000 live births) in Syrian Arab Republic in 2012 to that in 2013?
Ensure brevity in your answer.  1.03. What is the difference between the highest and the second highest Mortality rate(per 1,000 live births) in Central African Republic?
Give a very brief answer. 0.4. What is the difference between the highest and the second highest Mortality rate(per 1,000 live births) of El Salvador?
Make the answer very short. 0.3. What is the difference between the highest and the lowest Mortality rate(per 1,000 live births) in Central African Republic?
Your response must be concise. 3.6. What is the difference between the highest and the lowest Mortality rate(per 1,000 live births) of El Salvador?
Offer a very short reply. 1.7. 